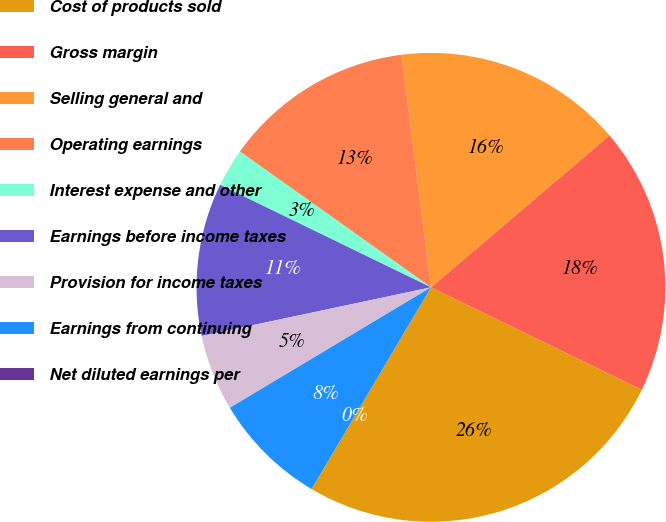Convert chart to OTSL. <chart><loc_0><loc_0><loc_500><loc_500><pie_chart><fcel>Cost of products sold<fcel>Gross margin<fcel>Selling general and<fcel>Operating earnings<fcel>Interest expense and other<fcel>Earnings before income taxes<fcel>Provision for income taxes<fcel>Earnings from continuing<fcel>Net diluted earnings per<nl><fcel>26.31%<fcel>18.42%<fcel>15.79%<fcel>13.16%<fcel>2.63%<fcel>10.53%<fcel>5.26%<fcel>7.9%<fcel>0.0%<nl></chart> 